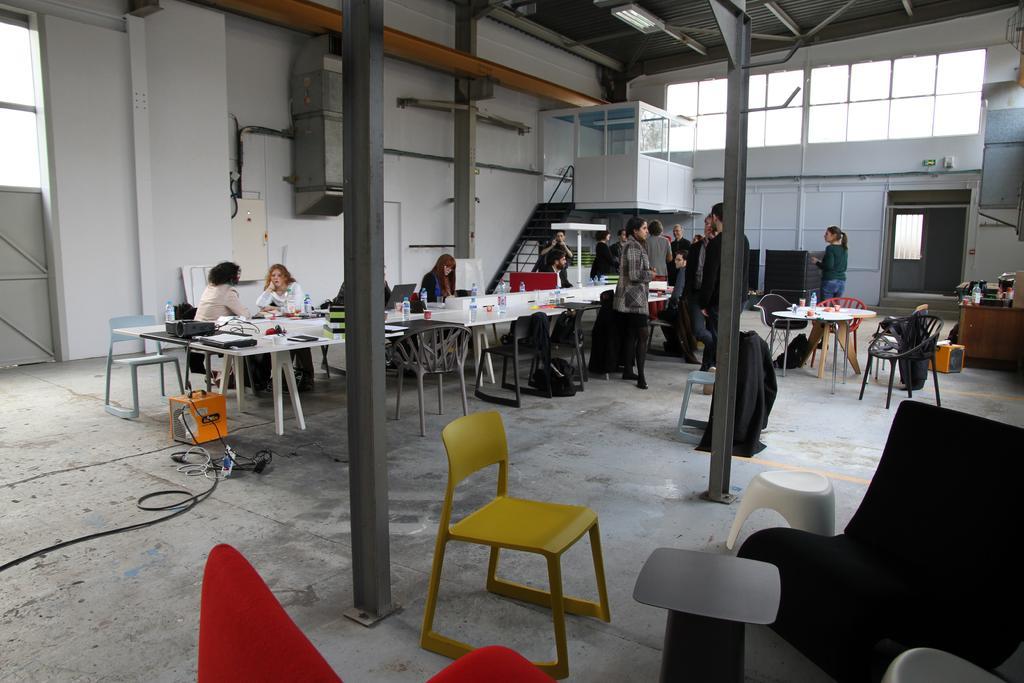Describe this image in one or two sentences. In this picture there are group of people standing near the table , there are table, chairs , flashlight and group of people sitting in the chairs and at the back ground we have staircase , room, windows,lights. 